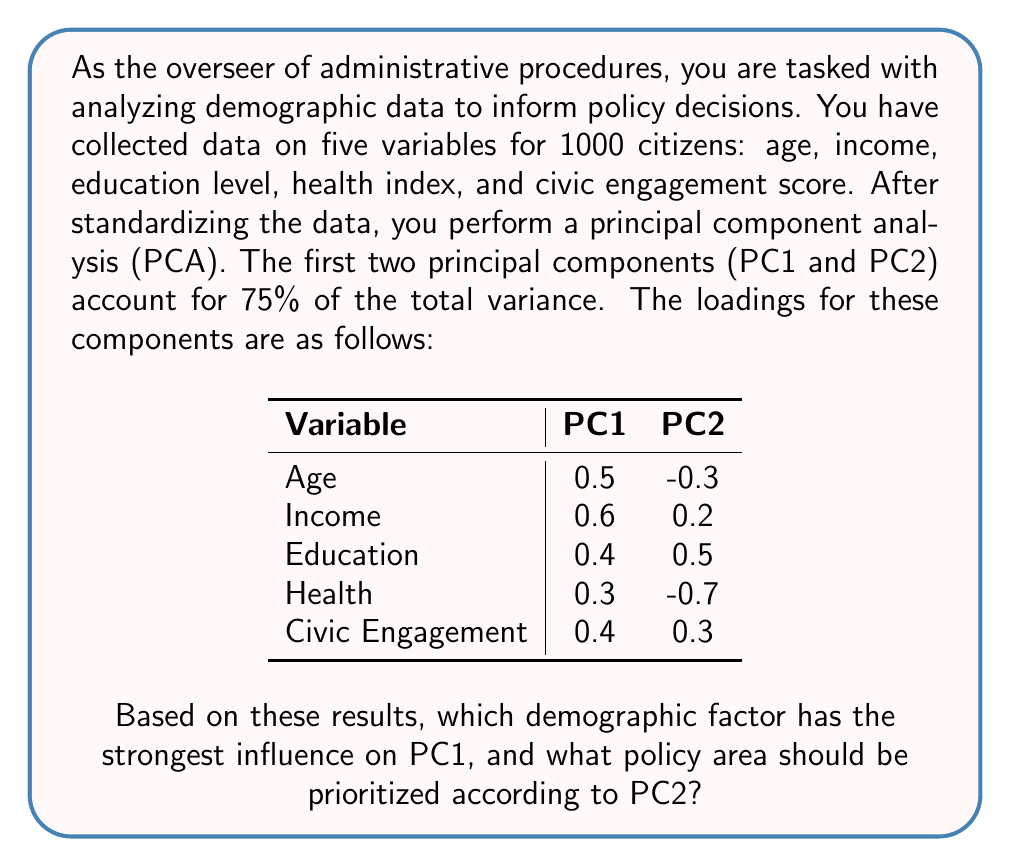Provide a solution to this math problem. To answer this question, we need to interpret the principal components based on their loadings:

1. Interpreting PC1:
   - Look at the absolute values of loadings in the PC1 column.
   - The largest absolute value indicates the strongest influence.
   - Income has the highest loading (0.6), followed by Age (0.5).
   - This suggests that PC1 is most strongly related to economic factors.

2. Interpreting PC2:
   - Examine the absolute values of loadings in the PC2 column.
   - Health has the highest absolute loading (-0.7), followed by Education (0.5).
   - The negative sign for Health indicates an inverse relationship.
   - This suggests that PC2 contrasts health status with education level.

3. Policy implications:
   - PC1 prioritizes economic factors, with Income having the strongest influence.
   - PC2 highlights a trade-off between Health (negative loading) and Education (positive loading).
   - The policy area to prioritize based on PC2 would be Health, as it has the largest absolute loading and indicates an area of concern (negative relationship).

Therefore, Income has the strongest influence on PC1, and Health should be the prioritized policy area according to PC2.
Answer: Income (PC1); Health (PC2) 